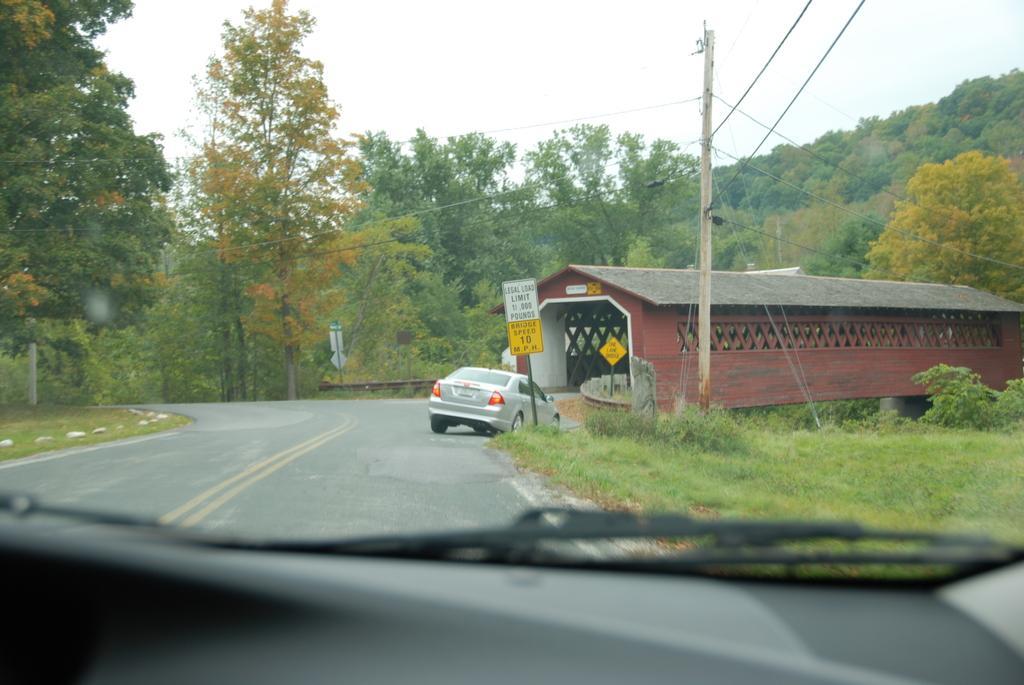In one or two sentences, can you explain what this image depicts? In the foreground of this picture we can see an object seems to be the vehicle. In the center we can see the green grass, plants, trees, car running on the road and we can see the text on the boards attached to the metal rods and we can see a pole, cables and a cabin. In the background we can see the sky, trees and some other objects. 